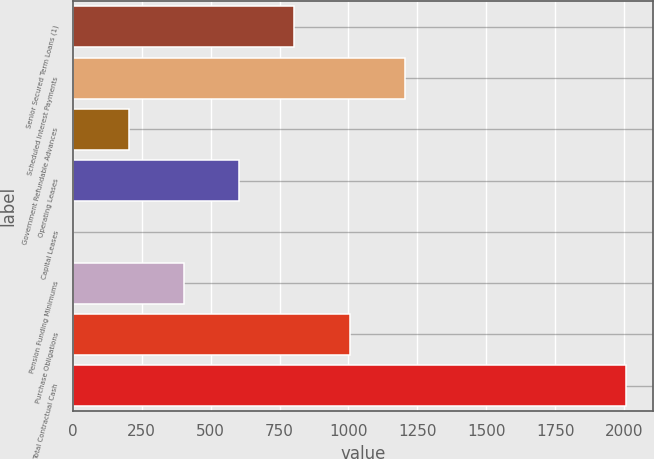Convert chart to OTSL. <chart><loc_0><loc_0><loc_500><loc_500><bar_chart><fcel>Senior Secured Term Loans (1)<fcel>Scheduled Interest Payments<fcel>Government Refundable Advances<fcel>Operating Leases<fcel>Capital Leases<fcel>Pension Funding Minimums<fcel>Purchase Obligations<fcel>Total Contractual Cash<nl><fcel>803.38<fcel>1204.32<fcel>201.97<fcel>602.91<fcel>1.5<fcel>402.44<fcel>1003.85<fcel>2006.2<nl></chart> 